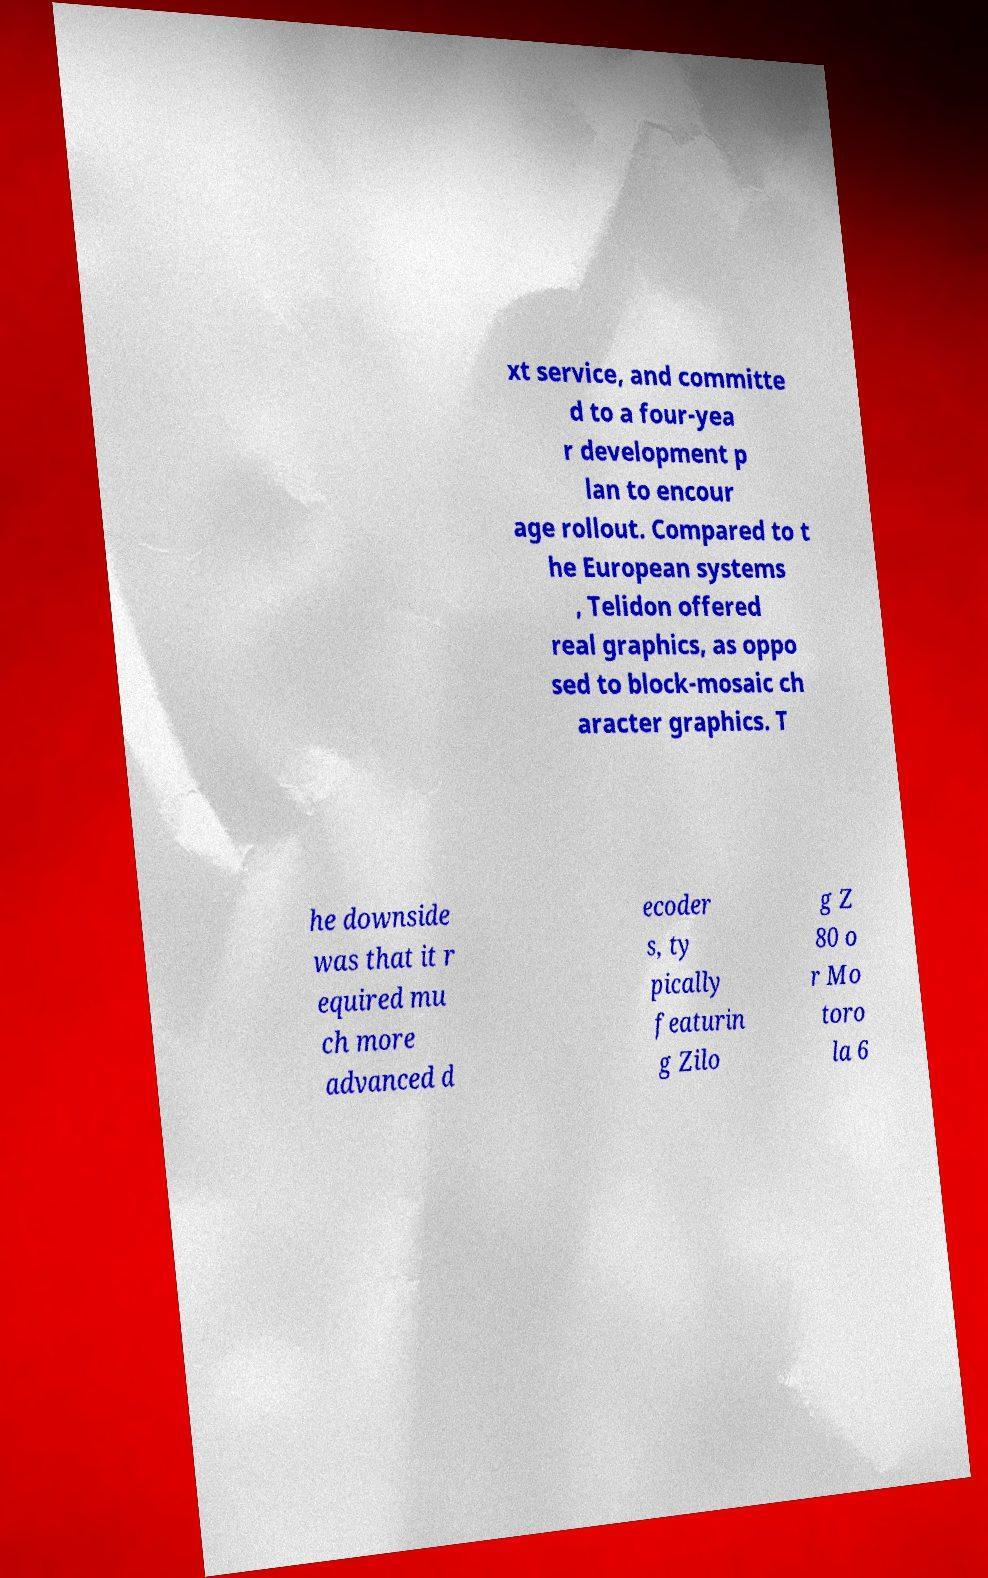I need the written content from this picture converted into text. Can you do that? xt service, and committe d to a four-yea r development p lan to encour age rollout. Compared to t he European systems , Telidon offered real graphics, as oppo sed to block-mosaic ch aracter graphics. T he downside was that it r equired mu ch more advanced d ecoder s, ty pically featurin g Zilo g Z 80 o r Mo toro la 6 